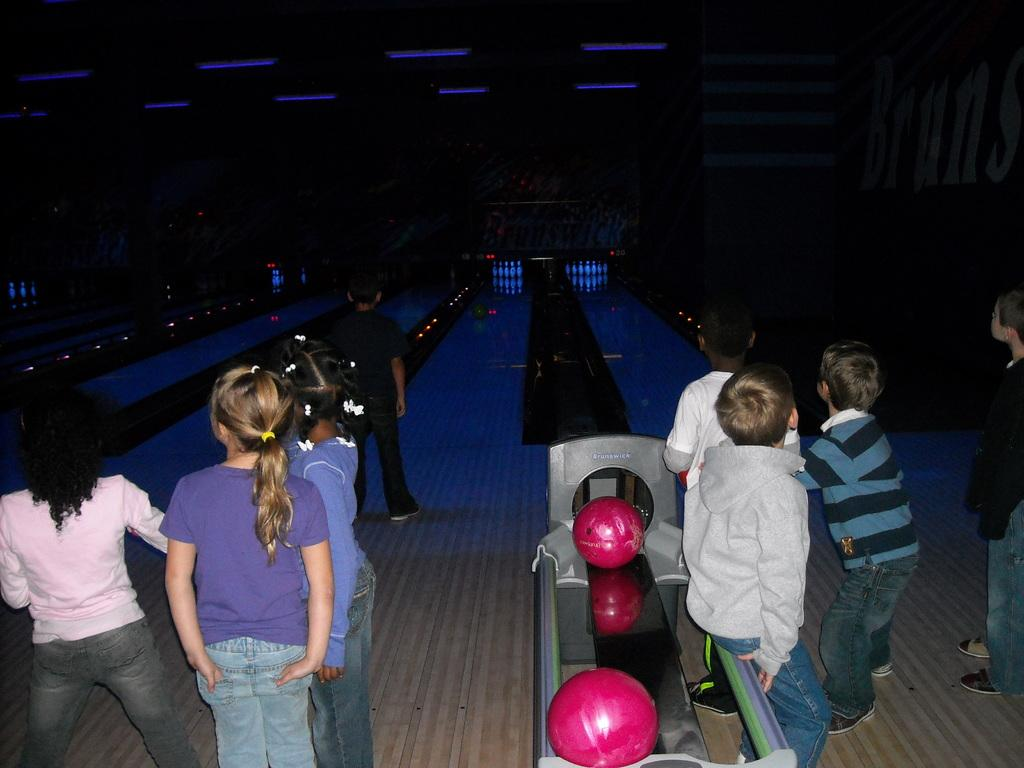What is happening in the image? There is a group of people standing in the image. What objects can be seen on the ground in the image? There are two pink balls in the image. What can be observed about the background of the image? The background of the image is dark. What type of knowledge can be gained from the book in the image? There is no book present in the image, so no knowledge can be gained from it. Can you see a giraffe in the image? No, there is no giraffe present in the image. 